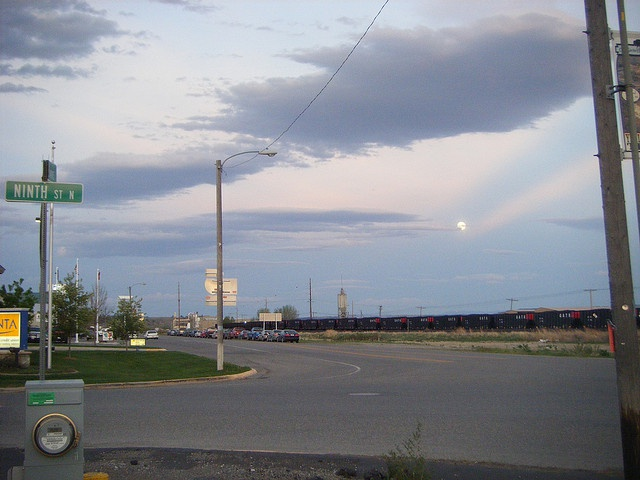Describe the objects in this image and their specific colors. I can see parking meter in gray, black, teal, and darkgreen tones, train in gray, black, and maroon tones, car in gray, black, and darkblue tones, car in gray and black tones, and car in gray, black, navy, and darkblue tones in this image. 